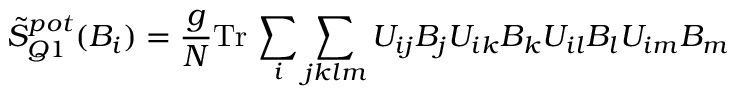Convert formula to latex. <formula><loc_0><loc_0><loc_500><loc_500>\tilde { S } _ { Q 1 } ^ { p o t } ( B _ { i } ) = \frac { g } { N } T r \, \sum _ { i } \sum _ { j k l m } U _ { i j } B _ { j } U _ { i k } B _ { k } U _ { i l } B _ { l } U _ { i m } B _ { m }</formula> 